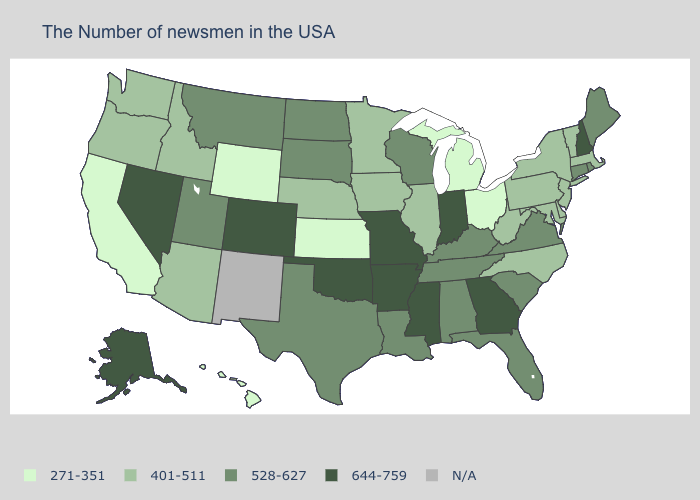Among the states that border Massachusetts , which have the lowest value?
Be succinct. Vermont, New York. Which states have the lowest value in the USA?
Concise answer only. Ohio, Michigan, Kansas, Wyoming, California, Hawaii. What is the highest value in the USA?
Concise answer only. 644-759. What is the value of Pennsylvania?
Write a very short answer. 401-511. Among the states that border Pennsylvania , does Ohio have the highest value?
Write a very short answer. No. What is the lowest value in the USA?
Write a very short answer. 271-351. Is the legend a continuous bar?
Be succinct. No. Name the states that have a value in the range 401-511?
Quick response, please. Massachusetts, Vermont, New York, New Jersey, Delaware, Maryland, Pennsylvania, North Carolina, West Virginia, Illinois, Minnesota, Iowa, Nebraska, Arizona, Idaho, Washington, Oregon. What is the value of Rhode Island?
Concise answer only. 528-627. Name the states that have a value in the range 401-511?
Be succinct. Massachusetts, Vermont, New York, New Jersey, Delaware, Maryland, Pennsylvania, North Carolina, West Virginia, Illinois, Minnesota, Iowa, Nebraska, Arizona, Idaho, Washington, Oregon. Which states have the lowest value in the USA?
Keep it brief. Ohio, Michigan, Kansas, Wyoming, California, Hawaii. What is the lowest value in states that border Arizona?
Concise answer only. 271-351. 